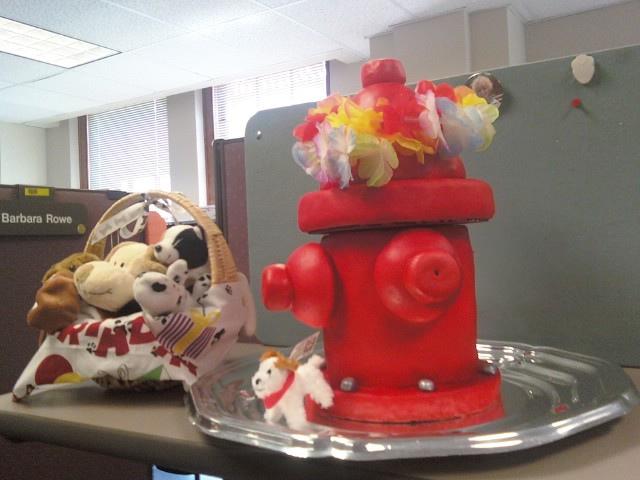What are the figures in front?
Give a very brief answer. Cake. Are there real fire hydrants in office buildings?
Write a very short answer. No. Whose name is visible in the photo?
Short answer required. Barbara rowe. What type of lighting is in the ceiling?
Quick response, please. Fluorescent. 